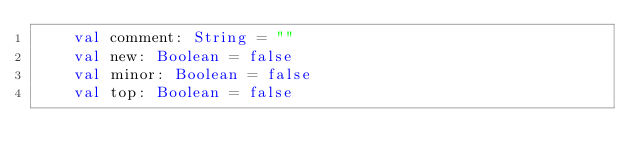<code> <loc_0><loc_0><loc_500><loc_500><_Kotlin_>    val comment: String = ""
    val new: Boolean = false
    val minor: Boolean = false
    val top: Boolean = false</code> 